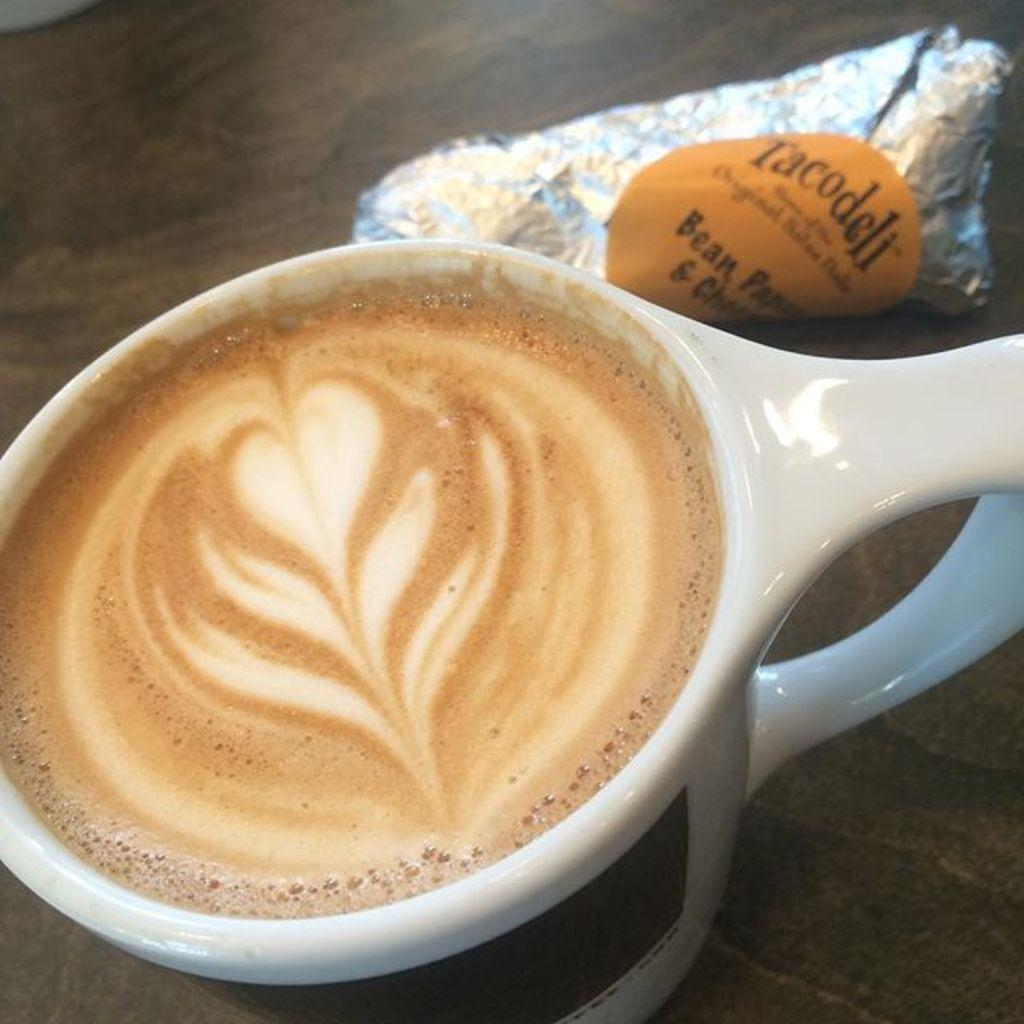What piece of furniture is present in the image? There is a table in the image. What is placed on the table? There is a coffee cup on the table. What else can be seen beside the coffee cup? There is an object beside the coffee cup. What type of drain is visible near the coffee cup? There is no drain present in the image. 